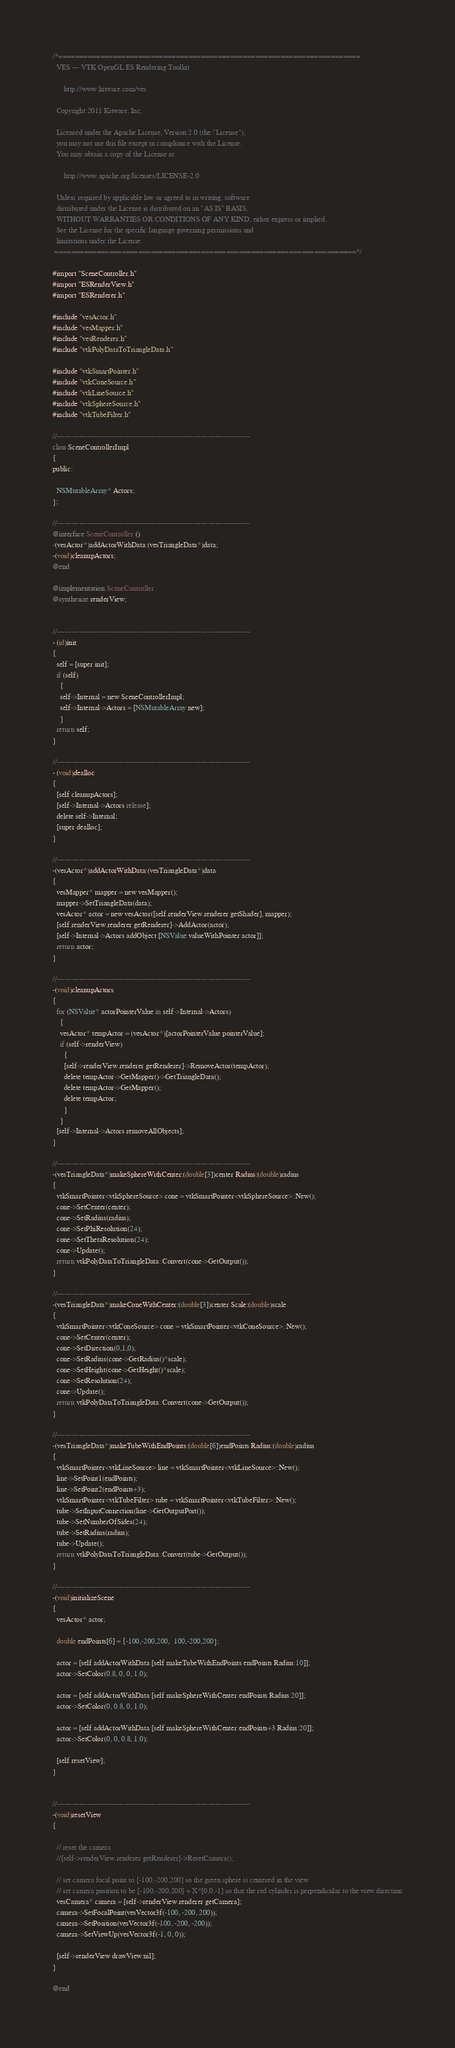Convert code to text. <code><loc_0><loc_0><loc_500><loc_500><_ObjectiveC_>/*========================================================================
  VES --- VTK OpenGL ES Rendering Toolkit

      http://www.kitware.com/ves

  Copyright 2011 Kitware, Inc.

  Licensed under the Apache License, Version 2.0 (the "License");
  you may not use this file except in compliance with the License.
  You may obtain a copy of the License at

      http://www.apache.org/licenses/LICENSE-2.0

  Unless required by applicable law or agreed to in writing, software
  distributed under the License is distributed on an "AS IS" BASIS,
  WITHOUT WARRANTIES OR CONDITIONS OF ANY KIND, either express or implied.
  See the License for the specific language governing permissions and
  limitations under the License.
 ========================================================================*/

#import "SceneController.h"
#import "ESRenderView.h"
#import "ESRenderer.h"

#include "vesActor.h"
#include "vesMapper.h"
#include "vesRenderer.h"
#include "vtkPolyDataToTriangleData.h"

#include "vtkSmartPointer.h"
#include "vtkConeSource.h"
#include "vtkLineSource.h"
#include "vtkSphereSource.h"
#include "vtkTubeFilter.h"

//------------------------------------------------------------------------------
class SceneControllerImpl
{
public:

  NSMutableArray* Actors;
};

//------------------------------------------------------------------------------
@interface SceneController ()
-(vesActor*)addActorWithData:(vesTriangleData*)data;
-(void)cleanupActors;
@end

@implementation SceneController
@synthesize renderView;


//------------------------------------------------------------------------------
- (id)init
{
  self = [super init];
  if (self)
    {
    self->Internal = new SceneControllerImpl;
    self->Internal->Actors = [NSMutableArray new];
    }
  return self;
}

//------------------------------------------------------------------------------
- (void)dealloc
{
  [self cleanupActors];
  [self->Internal->Actors release];
  delete self->Internal;
  [super dealloc];
}

//------------------------------------------------------------------------------
-(vesActor*)addActorWithData:(vesTriangleData*)data
{
  vesMapper* mapper = new vesMapper();
  mapper->SetTriangleData(data);
  vesActor* actor = new vesActor([self.renderView.renderer getShader], mapper);
  [self.renderView.renderer getRenderer]->AddActor(actor);
  [self->Internal->Actors addObject:[NSValue valueWithPointer:actor]];
  return actor;
}

//------------------------------------------------------------------------------
-(void)cleanupActors
{
  for (NSValue* actorPointerValue in self->Internal->Actors)
    {
    vesActor* tempActor = (vesActor*)[actorPointerValue pointerValue];
    if (self->renderView)
      {
      [self->renderView.renderer getRenderer]->RemoveActor(tempActor);
      delete tempActor->GetMapper()->GetTriangleData();
      delete tempActor->GetMapper();
      delete tempActor;
      }
    }
  [self->Internal->Actors removeAllObjects];
}

//------------------------------------------------------------------------------
-(vesTriangleData*)makeSphereWithCenter:(double[3])center Radius:(double)radius
{
  vtkSmartPointer<vtkSphereSource> cone = vtkSmartPointer<vtkSphereSource>::New();
  cone->SetCenter(center);
  cone->SetRadius(radius);
  cone->SetPhiResolution(24);
  cone->SetThetaResolution(24);
  cone->Update();
  return vtkPolyDataToTriangleData::Convert(cone->GetOutput());
}

//------------------------------------------------------------------------------
-(vesTriangleData*)makeConeWithCenter:(double[3])center Scale:(double)scale
{
  vtkSmartPointer<vtkConeSource> cone = vtkSmartPointer<vtkConeSource>::New();
  cone->SetCenter(center);
  cone->SetDirection(0,1,0);
  cone->SetRadius(cone->GetRadius()*scale);
  cone->SetHeight(cone->GetHeight()*scale);
  cone->SetResolution(24);
  cone->Update();
  return vtkPolyDataToTriangleData::Convert(cone->GetOutput());
}

//------------------------------------------------------------------------------
-(vesTriangleData*)makeTubeWithEndPoints:(double[6])endPoints Radius:(double)radius
{
  vtkSmartPointer<vtkLineSource> line = vtkSmartPointer<vtkLineSource>::New();
  line->SetPoint1(endPoints);
  line->SetPoint2(endPoints+3);
  vtkSmartPointer<vtkTubeFilter> tube = vtkSmartPointer<vtkTubeFilter>::New();
  tube->SetInputConnection(line->GetOutputPort());
  tube->SetNumberOfSides(24);
  tube->SetRadius(radius);
  tube->Update();
  return vtkPolyDataToTriangleData::Convert(tube->GetOutput());
}

//------------------------------------------------------------------------------
-(void)initializeScene
{
  vesActor* actor;

  double endPoints[6] = {-100,-200,200,  100,-200,200};

  actor = [self addActorWithData:[self makeTubeWithEndPoints:endPoints Radius:10]];
  actor->SetColor(0.8, 0, 0, 1.0);

  actor = [self addActorWithData:[self makeSphereWithCenter:endPoints Radius:20]];
  actor->SetColor(0, 0.8, 0, 1.0);

  actor = [self addActorWithData:[self makeSphereWithCenter:endPoints+3 Radius:20]];
  actor->SetColor(0, 0, 0.8, 1.0);

  [self resetView];
}


//------------------------------------------------------------------------------
-(void)resetView
{

  // reset the camera
  //[self->renderView.renderer getRenderer]->ResetCamera();

  // set camera focal point to [-100,-200,200] so the green sphere is centered in the view
  // set camera position to be [-100,-200,200] + X*[0,0,-1] so that the red cylinder is perpendicular to the view direction
  vesCamera* camera = [self->renderView.renderer getCamera];
  camera->SetFocalPoint(vesVector3f(-100, -200, 200));
  camera->SetPosition(vesVector3f(-100, -200, -200));
  camera->SetViewUp(vesVector3f(-1, 0, 0));

  [self->renderView drawView:nil];
}

@end
</code> 